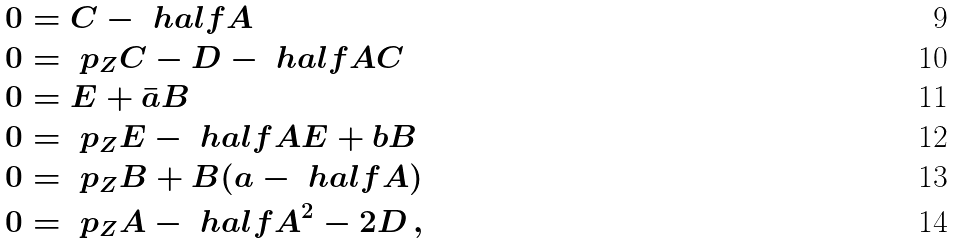<formula> <loc_0><loc_0><loc_500><loc_500>0 & = C - \ h a l f A \\ 0 & = \ p _ { Z } C - D - \ h a l f A C \\ 0 & = E + \bar { a } B \\ 0 & = \ p _ { Z } E - \ h a l f A E + b B \\ 0 & = \ p _ { Z } B + B ( a - \ h a l f A ) \\ 0 & = \ p _ { Z } A - \ h a l f A ^ { 2 } - 2 D \, ,</formula> 